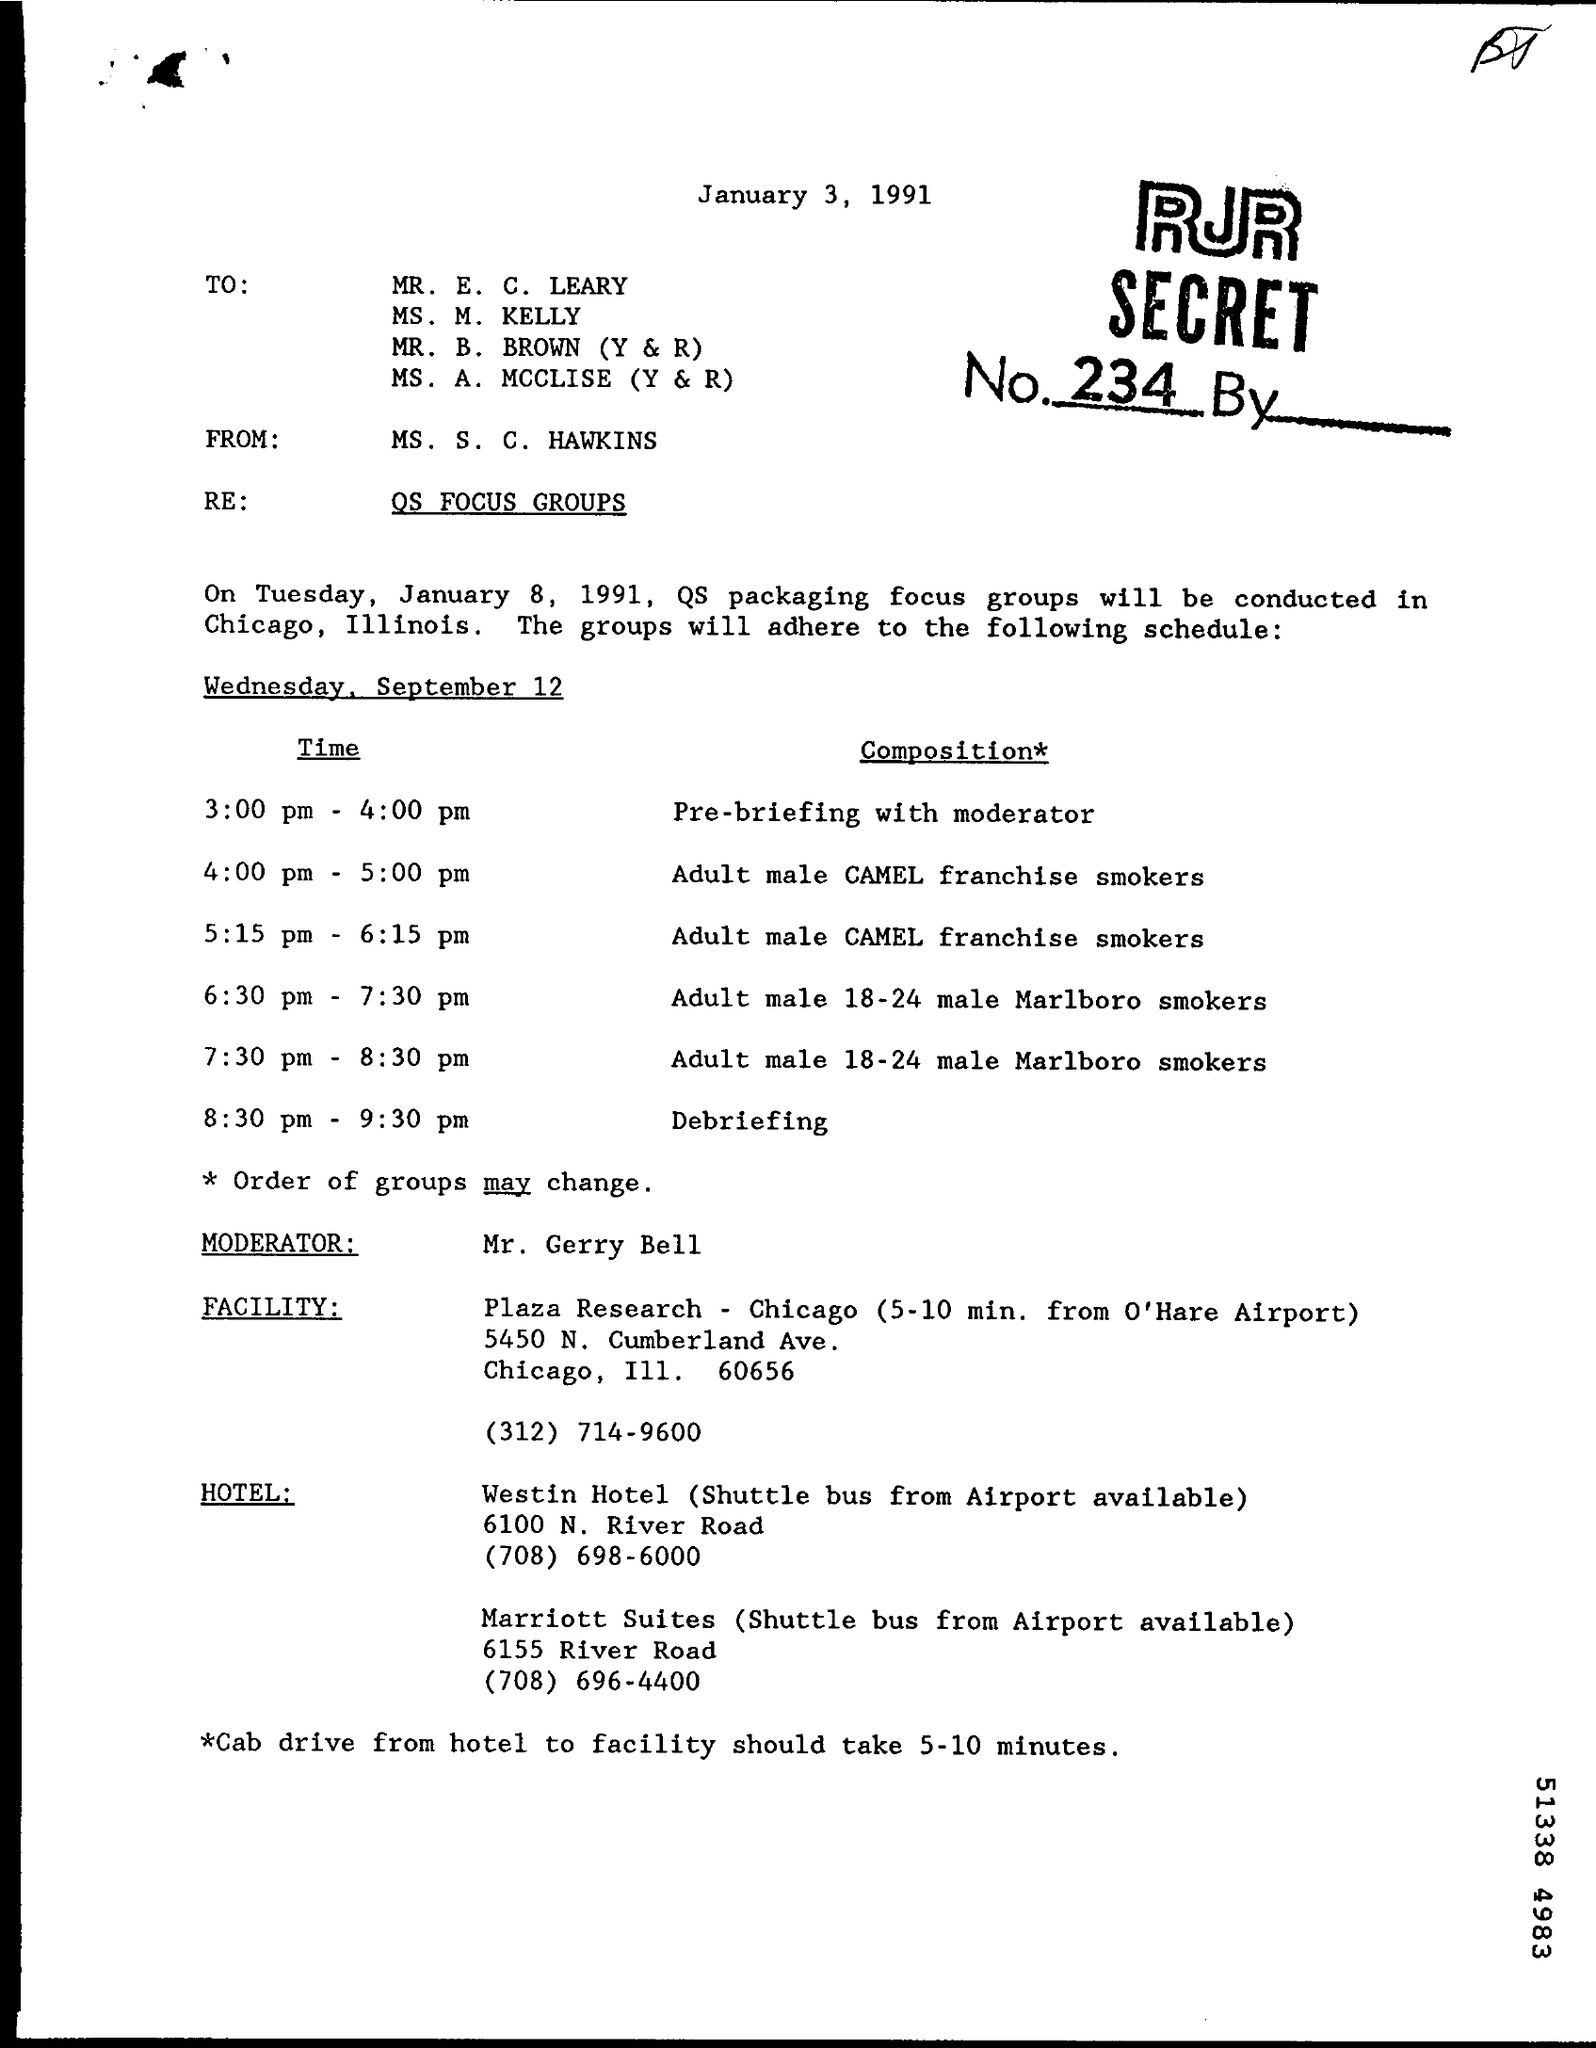Outline some significant characteristics in this image. The debriefing is scheduled to take place between 8:30 pm and 9:30 pm. The facility is the Plaza Research facility. The moderator is Mr. Gerry Bell. The QC packaging focus groups will be conducted in Chicago, Illinois. The pre-briefing with the moderator is scheduled to take place from 3:00 pm to 4:00 pm. 